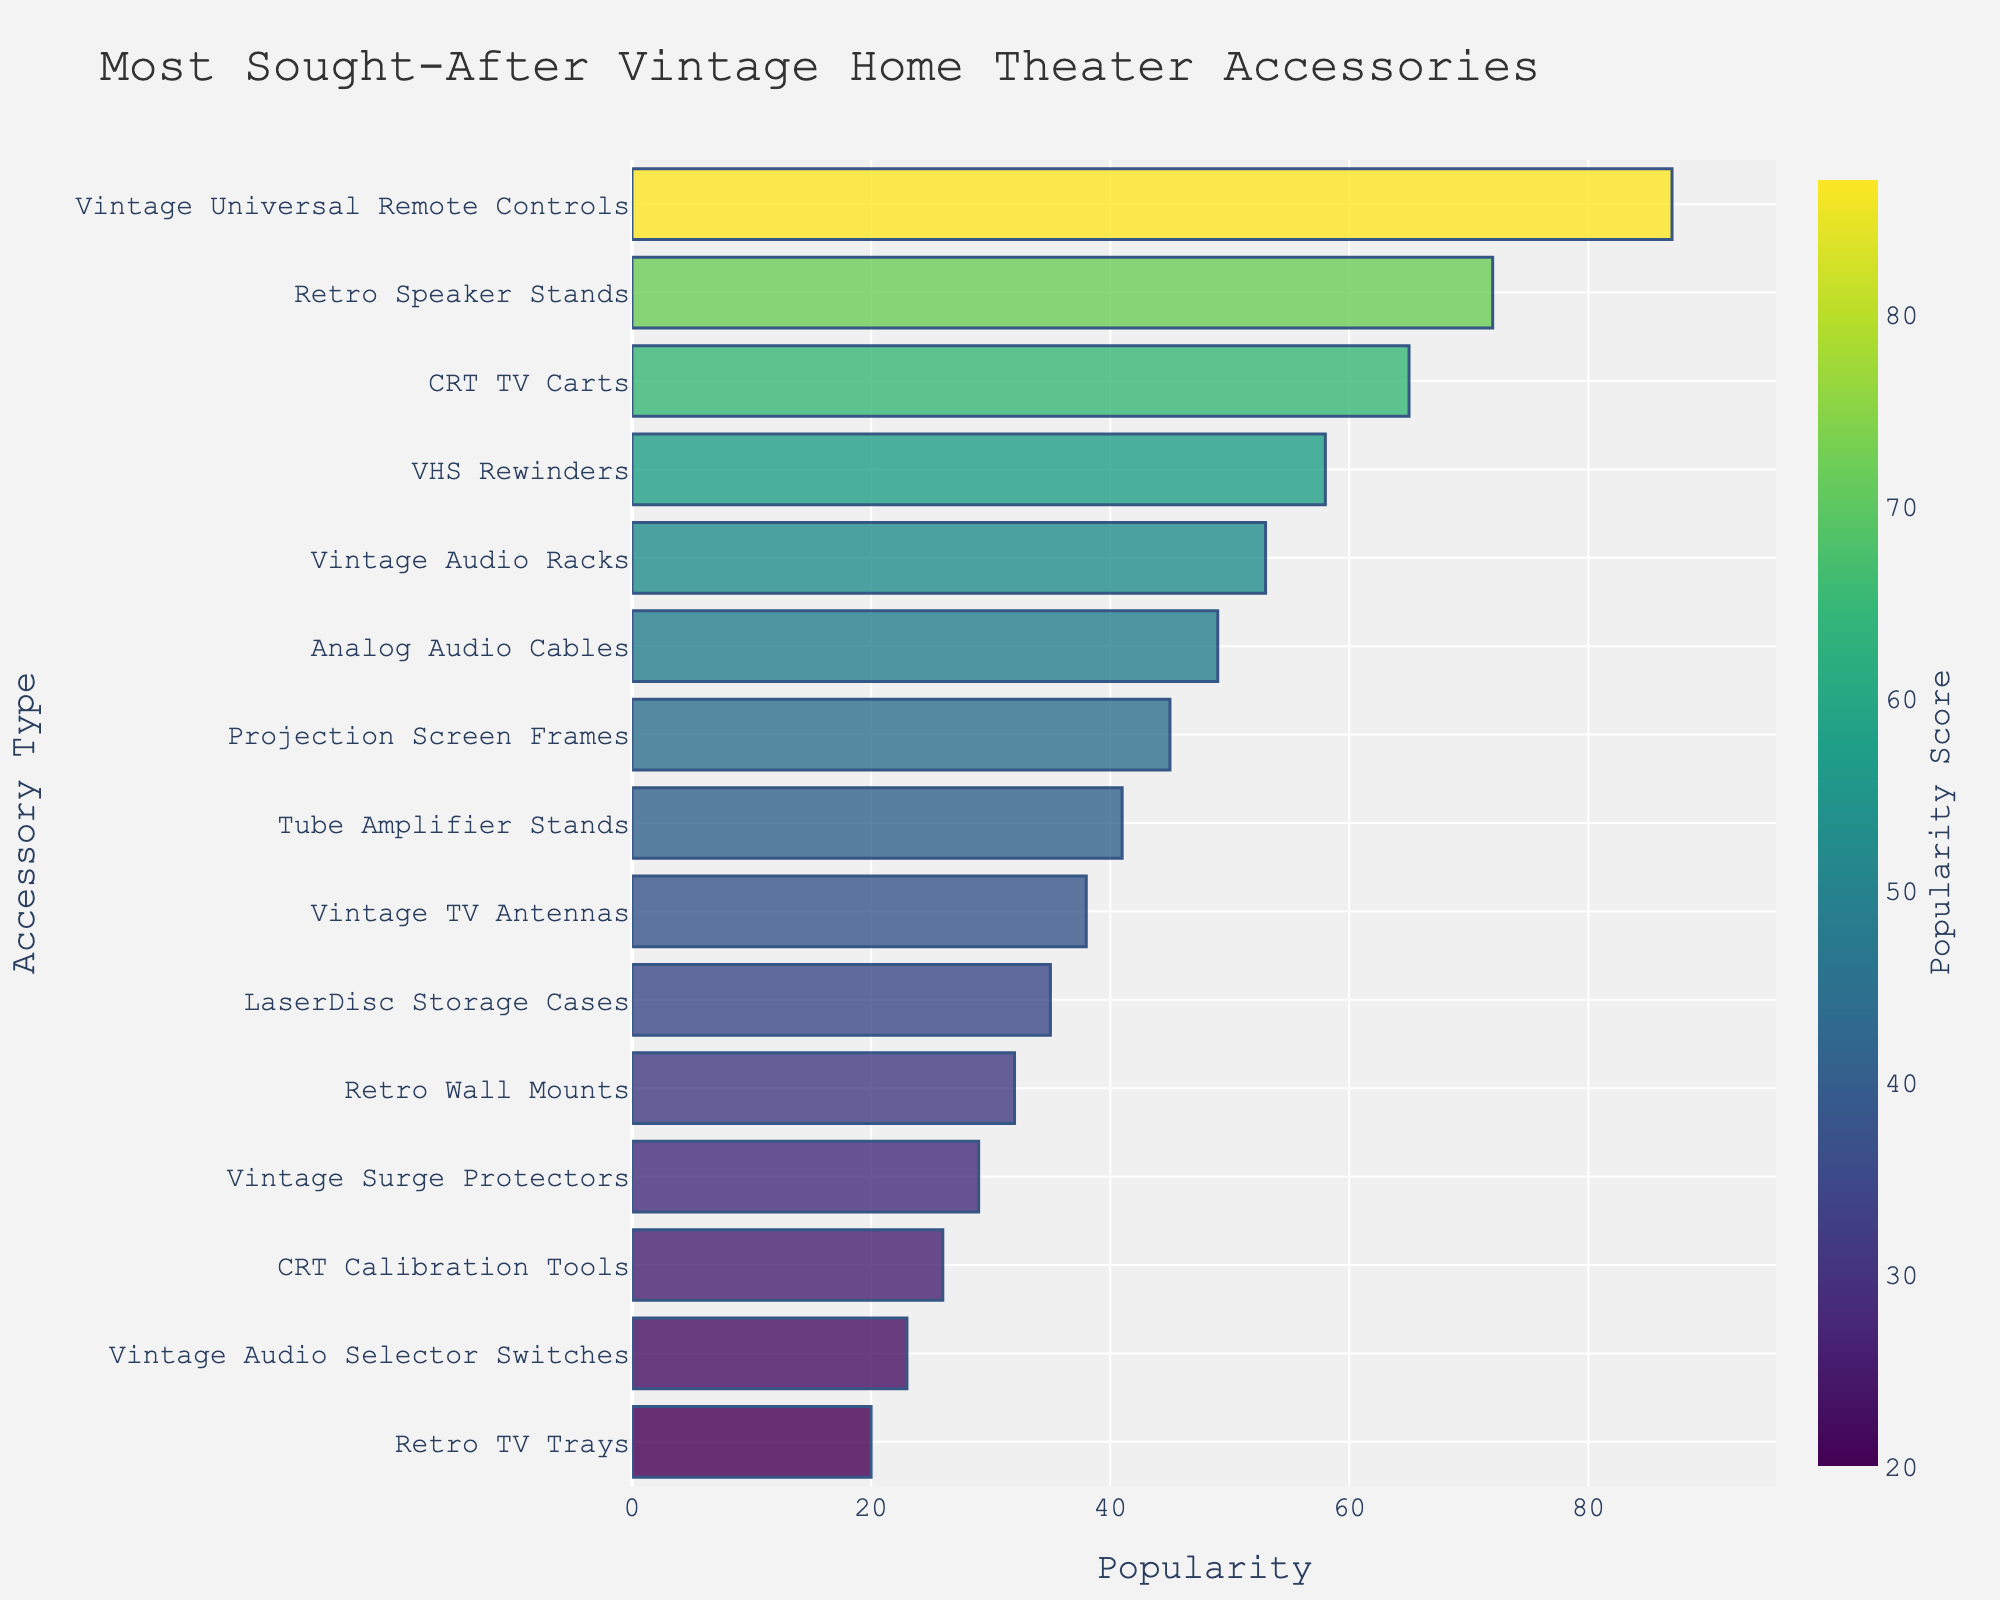Which accessory type has the highest demand score? By examining the length of the bars, the Vintage Universal Remote Controls have the highest demand score of 87.
Answer: Vintage Universal Remote Controls What is the total demand score for Retro Speaker Stands and CRT TV Carts combined? The demand score for Retro Speaker Stands is 72 and CRT TV Carts is 65. Adding these together, 72 + 65 = 137.
Answer: 137 How many accessories have a demand score above 50? Observing the bars, the accessories with demand scores above 50 are Vintage Universal Remote Controls, Retro Speaker Stands, CRT TV Carts, VHS Rewinders, Vintage Audio Racks, and Analog Audio Cables, making a total of 6 accessories.
Answer: 6 Which accessory type has the lowest demand score, and what is it? Scanning the bars, the Retro TV Trays have the shortest bar with the lowest demand score of 20.
Answer: Retro TV Trays, 20 Compare the demand scores of VHS Rewinders and LaserDisc Storage Cases. Which is higher, and by how much? VHS Rewinders have a demand score of 58, while LaserDisc Storage Cases have 35. The difference is 58 - 35 = 23. Therefore, VHS Rewinders' demand score is higher by 23.
Answer: VHS Rewinders, 23 What is the average demand score of Analog Audio Cables, Projection Screen Frames, and Tube Amplifier Stands? The demand scores are 49, 45, and 41 respectively. Adding them together gives 49 + 45 + 41 = 135. Dividing by 3 gives 135 / 3 = 45.
Answer: 45 Is the demand score of Vintage Surge Protectors greater than or less than half the demand score of Vintage Universal Remote Controls? Half the demand score of Vintage Universal Remote Controls is 87 / 2 = 43.5. The demand score of Vintage Surge Protectors is 29. Since 29 < 43.5, the demand score of Vintage Surge Protectors is less than half of Vintage Universal Remote Controls.
Answer: Less than Describe the color gradient used in the bar chart and what it signifies. The bar chart uses a Viridis color scale, transitioning from shades of yellow through green to shades of blue, signifying increasing demand scores as the color progresses towards blue.
Answer: Yellow to blue gradient Sort the accessories based on their demand scores in ascending order. By observing the bars' lengths and their positions, the accessories sorted in ascending order are: Retro TV Trays, Vintage Audio Selector Switches, CRT Calibration Tools, Vintage Surge Protectors, Retro Wall Mounts, LaserDisc Storage Cases, Vintage TV Antennas, Tube Amplifier Stands, Projection Screen Frames, Analog Audio Cables, Vintage Audio Racks, VHS Rewinders, CRT TV Carts, Retro Speaker Stands, and Vintage Universal Remote Controls.
Answer: Retro TV Trays, Vintage Audio Selector Switches, CRT Calibration Tools, Vintage Surge Protectors, Retro Wall Mounts, LaserDisc Storage Cases, Vintage TV Antennas, Tube Amplifier Stands, Projection Screen Frames, Analog Audio Cables, Vintage Audio Racks, VHS Rewinders, CRT TV Carts, Retro Speaker Stands, Vintage Universal Remote Controls 